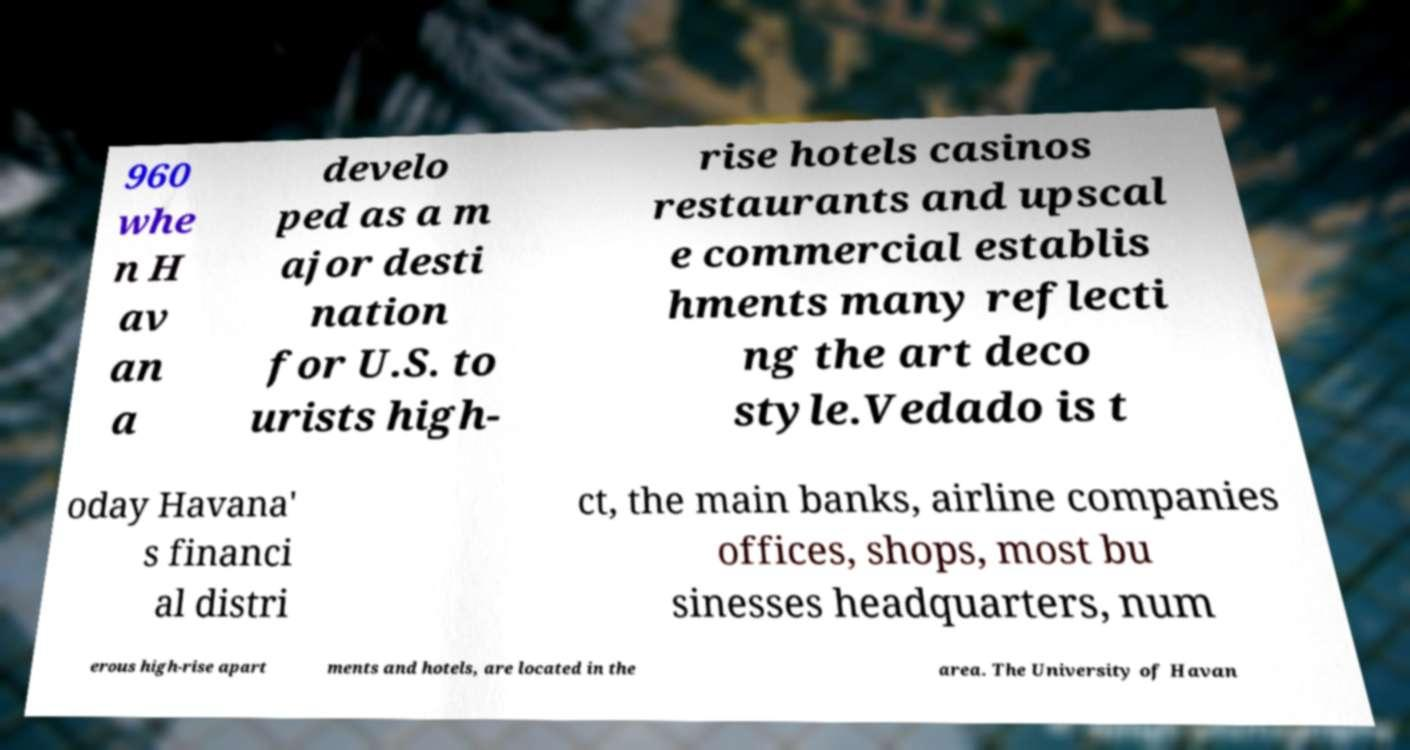I need the written content from this picture converted into text. Can you do that? 960 whe n H av an a develo ped as a m ajor desti nation for U.S. to urists high- rise hotels casinos restaurants and upscal e commercial establis hments many reflecti ng the art deco style.Vedado is t oday Havana' s financi al distri ct, the main banks, airline companies offices, shops, most bu sinesses headquarters, num erous high-rise apart ments and hotels, are located in the area. The University of Havan 